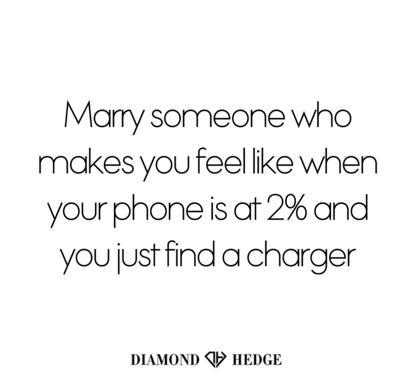What other everyday situations could symbolize important qualities in a life partner? Finding an umbrella right as it starts raining could symbolize a partner's ability to provide protection and foresight. Similarly, catching the last train home might represent reliability and the comfort of knowing you can always make it back to safety with them. 